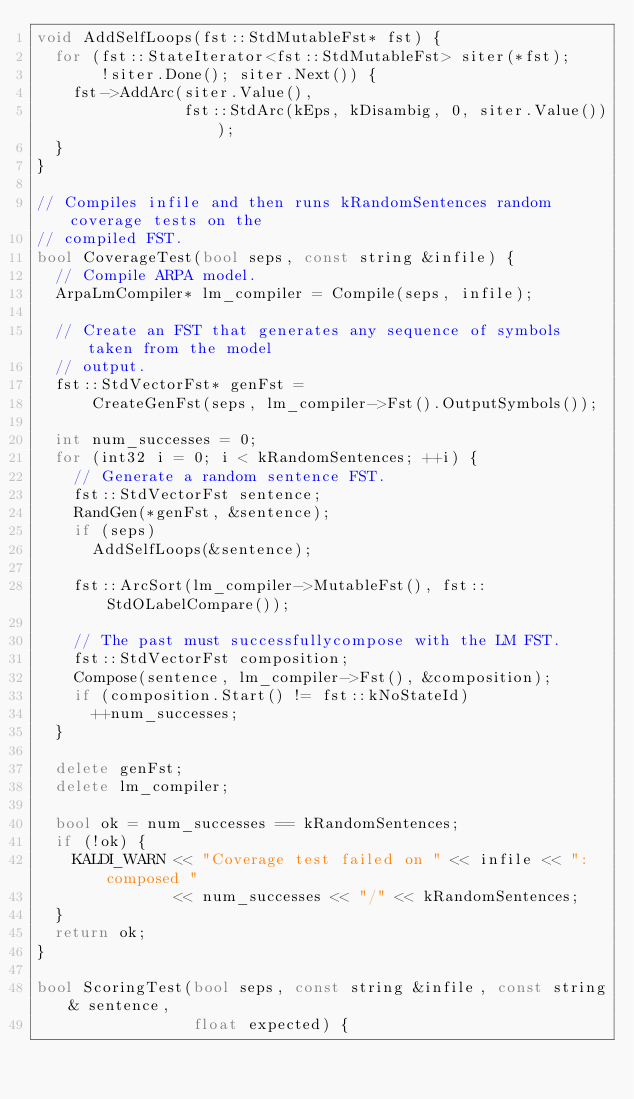<code> <loc_0><loc_0><loc_500><loc_500><_C++_>void AddSelfLoops(fst::StdMutableFst* fst) {
  for (fst::StateIterator<fst::StdMutableFst> siter(*fst);
       !siter.Done(); siter.Next()) {
    fst->AddArc(siter.Value(),
                fst::StdArc(kEps, kDisambig, 0, siter.Value()));
  }
}

// Compiles infile and then runs kRandomSentences random coverage tests on the
// compiled FST.
bool CoverageTest(bool seps, const string &infile) {
  // Compile ARPA model.
  ArpaLmCompiler* lm_compiler = Compile(seps, infile);

  // Create an FST that generates any sequence of symbols taken from the model
  // output.
  fst::StdVectorFst* genFst =
      CreateGenFst(seps, lm_compiler->Fst().OutputSymbols());

  int num_successes = 0;
  for (int32 i = 0; i < kRandomSentences; ++i) {
    // Generate a random sentence FST.
    fst::StdVectorFst sentence;
    RandGen(*genFst, &sentence);
    if (seps)
      AddSelfLoops(&sentence);

    fst::ArcSort(lm_compiler->MutableFst(), fst::StdOLabelCompare());

    // The past must successfullycompose with the LM FST.
    fst::StdVectorFst composition;
    Compose(sentence, lm_compiler->Fst(), &composition);
    if (composition.Start() != fst::kNoStateId)
      ++num_successes;
  }

  delete genFst;
  delete lm_compiler;

  bool ok = num_successes == kRandomSentences;
  if (!ok) {
    KALDI_WARN << "Coverage test failed on " << infile << ": composed "
               << num_successes << "/" << kRandomSentences;
  }
  return ok;
}

bool ScoringTest(bool seps, const string &infile, const string& sentence,
                 float expected) {</code> 